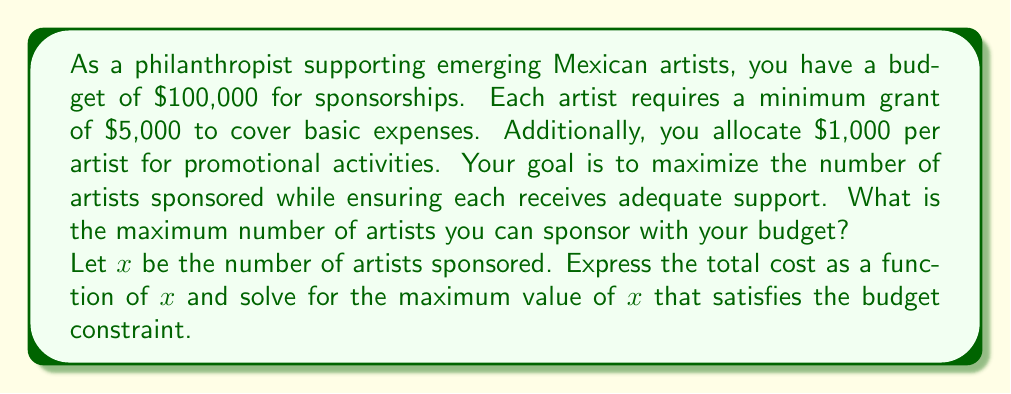Solve this math problem. To solve this optimization problem, we'll follow these steps:

1) Express the total cost as a function of $x$:
   - Each artist receives a $5,000 grant
   - Each artist has $1,000 allocated for promotional activities
   - Total cost per artist: $5,000 + $1,000 = $6,000
   
   The cost function is thus:
   $$C(x) = 6000x$$

2) Set up the inequality to represent the budget constraint:
   $$6000x \leq 100000$$

3) Solve for x:
   $$x \leq \frac{100000}{6000} = \frac{50}{3} = 16.67$$

4) Since $x$ represents the number of artists and must be a whole number, we round down to the nearest integer:
   $$x = 16$$

5) Verify the solution:
   $$C(16) = 6000 \cdot 16 = 96000$$
   which is within the $100,000 budget.

Therefore, the maximum number of artists that can be sponsored is 16.
Answer: 16 artists 